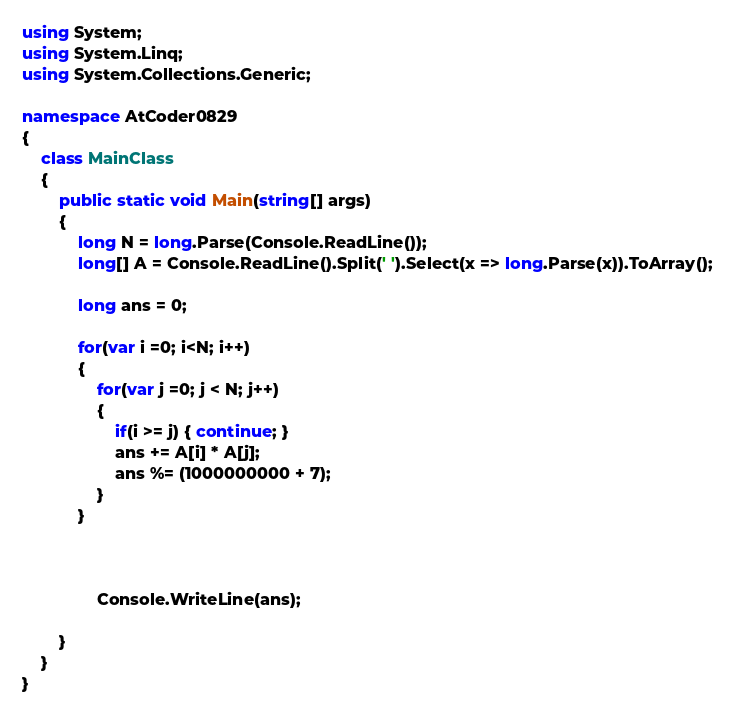Convert code to text. <code><loc_0><loc_0><loc_500><loc_500><_C#_>using System;
using System.Linq;
using System.Collections.Generic;

namespace AtCoder0829
{
    class MainClass
    {
        public static void Main(string[] args)
        {
            long N = long.Parse(Console.ReadLine());
            long[] A = Console.ReadLine().Split(' ').Select(x => long.Parse(x)).ToArray();

            long ans = 0;

            for(var i =0; i<N; i++)
            {
                for(var j =0; j < N; j++)
                {
                    if(i >= j) { continue; }
                    ans += A[i] * A[j];
                    ans %= (1000000000 + 7);
                }
            }



                Console.WriteLine(ans);
            
        }
    }
}

</code> 